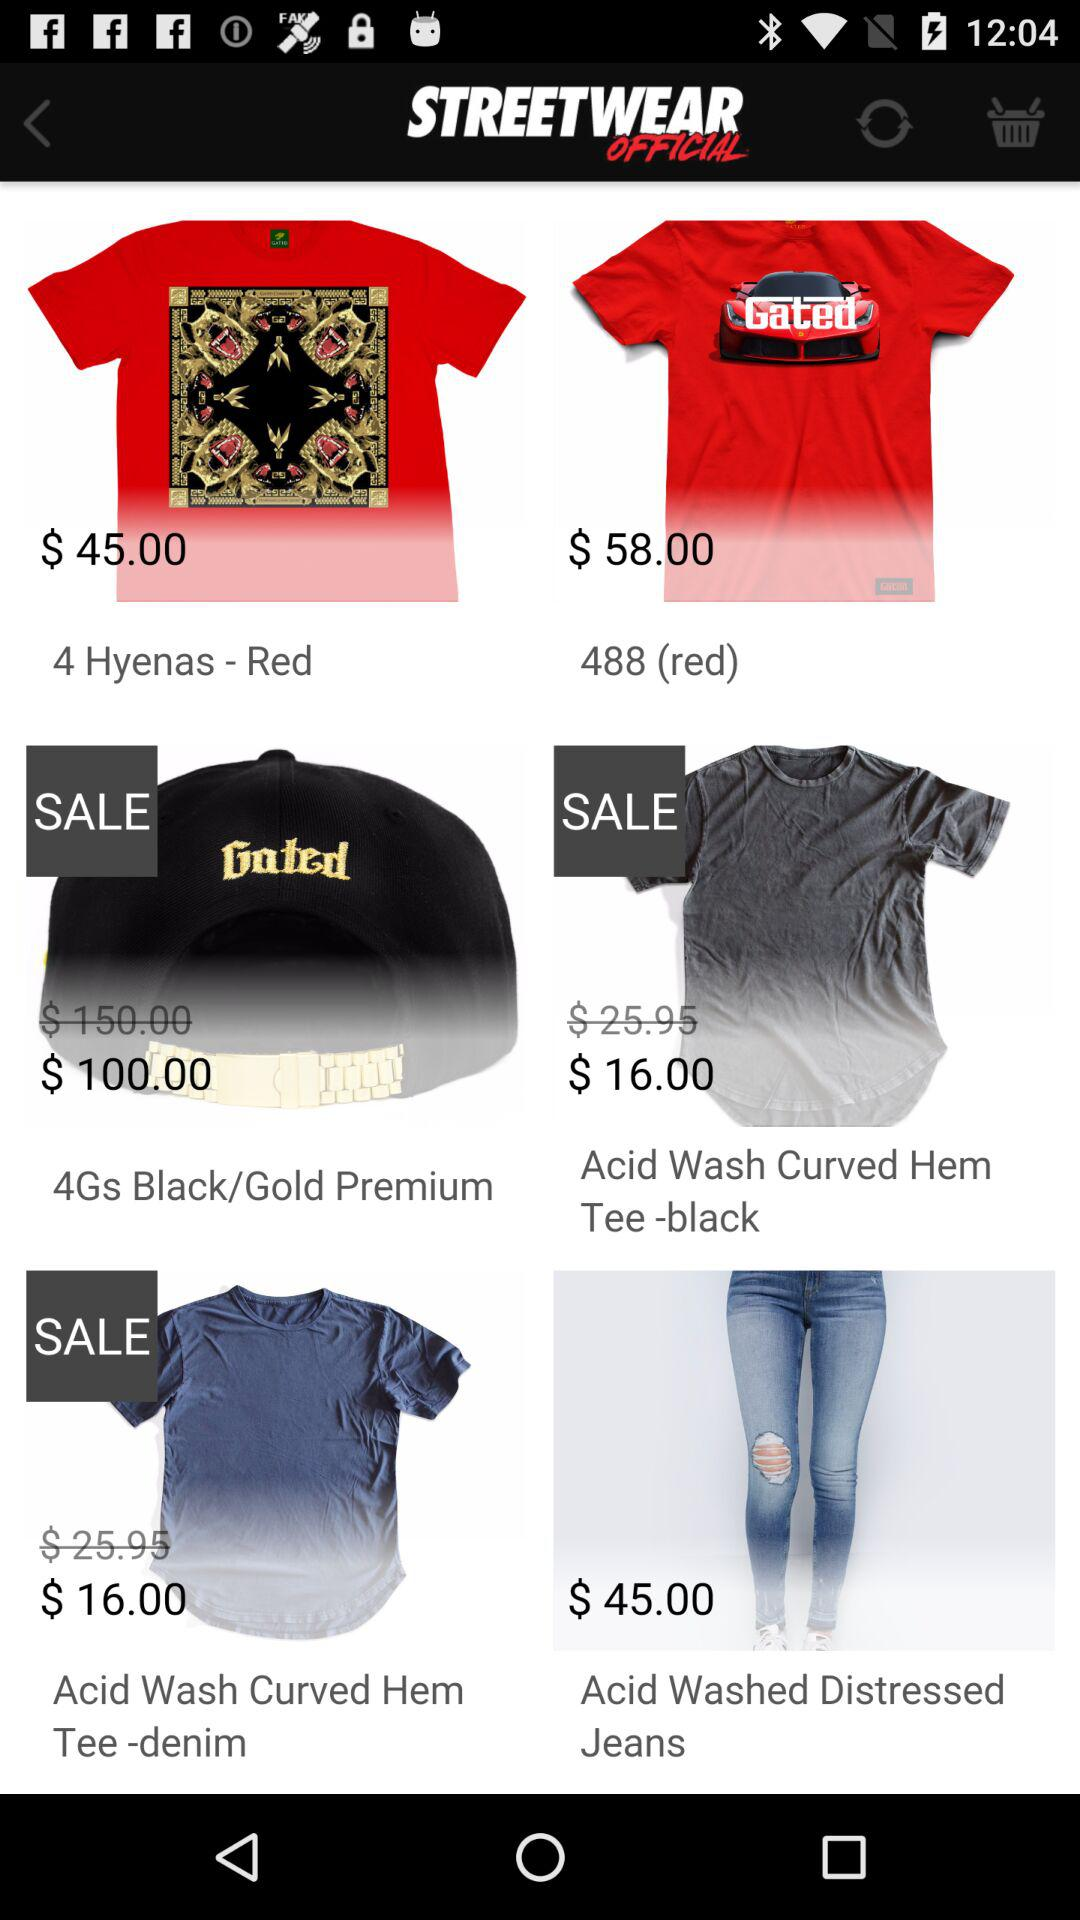What is the price of "Acid Washed Distressed Jeans"? The price is $45.00. 